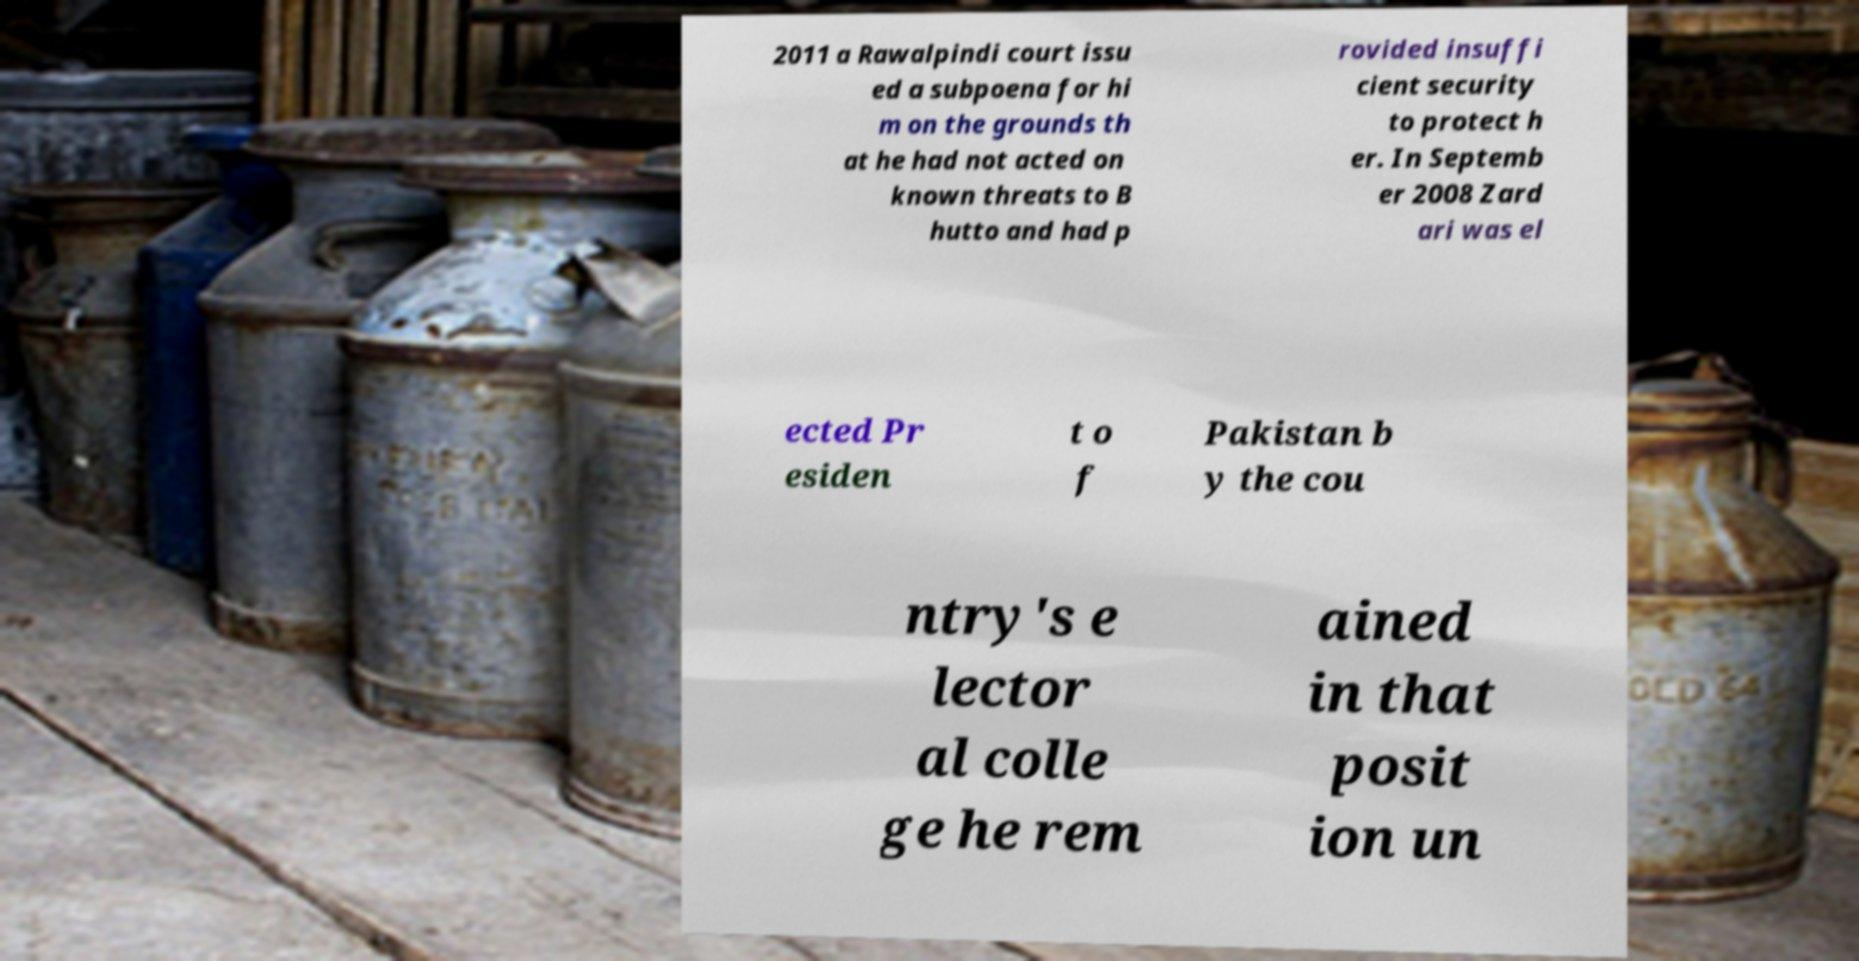Please identify and transcribe the text found in this image. 2011 a Rawalpindi court issu ed a subpoena for hi m on the grounds th at he had not acted on known threats to B hutto and had p rovided insuffi cient security to protect h er. In Septemb er 2008 Zard ari was el ected Pr esiden t o f Pakistan b y the cou ntry's e lector al colle ge he rem ained in that posit ion un 